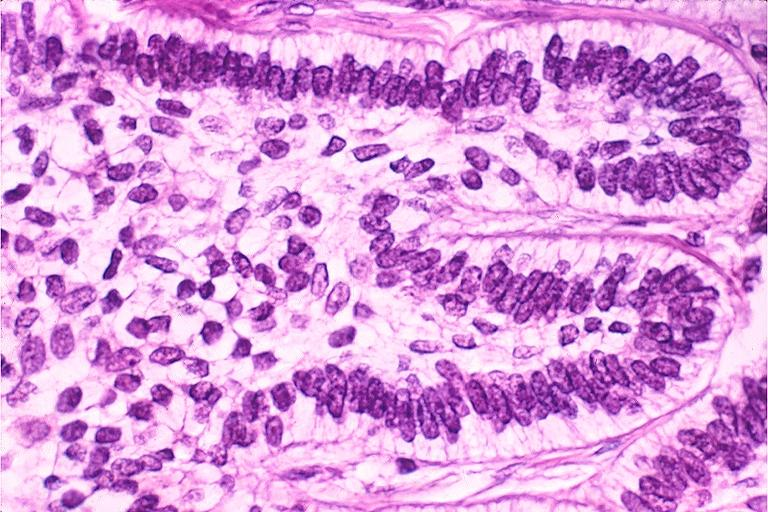what is present?
Answer the question using a single word or phrase. Oral 